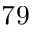<formula> <loc_0><loc_0><loc_500><loc_500>^ { 7 } 9</formula> 